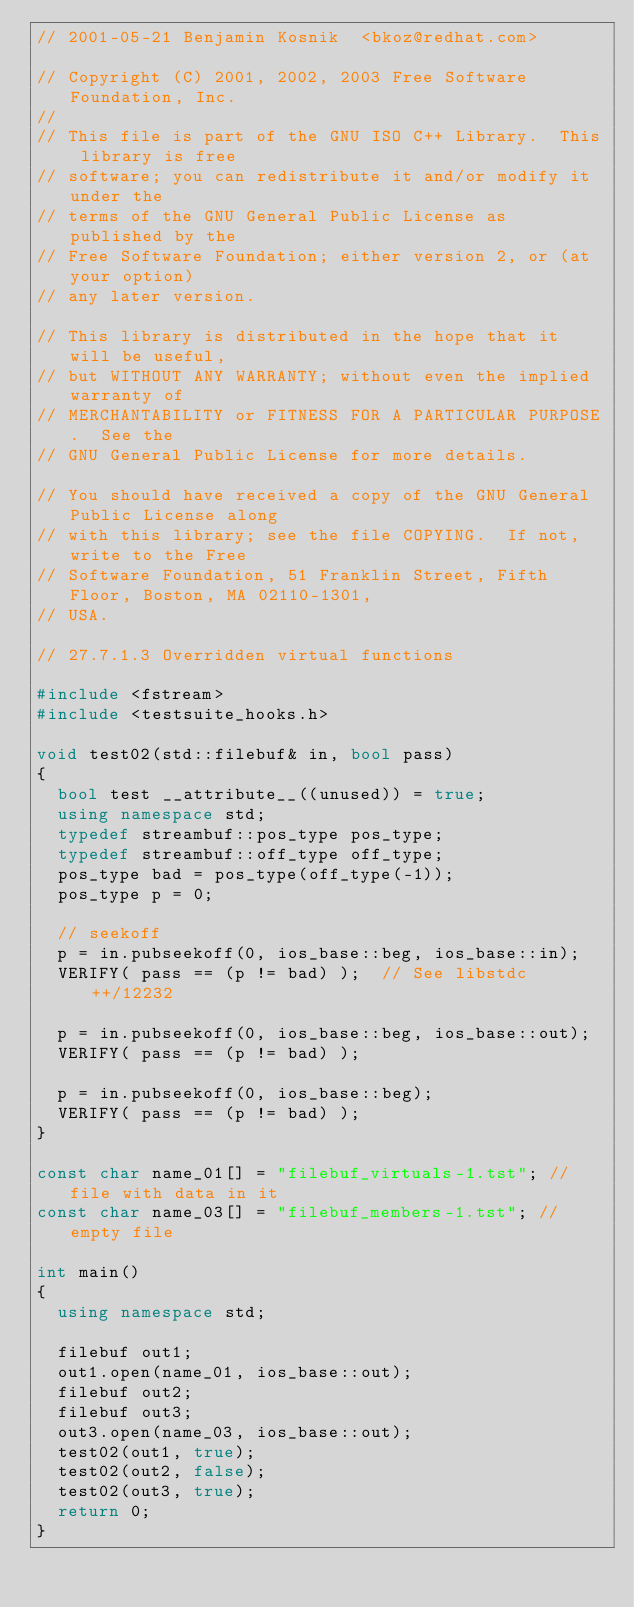Convert code to text. <code><loc_0><loc_0><loc_500><loc_500><_C++_>// 2001-05-21 Benjamin Kosnik  <bkoz@redhat.com>

// Copyright (C) 2001, 2002, 2003 Free Software Foundation, Inc.
//
// This file is part of the GNU ISO C++ Library.  This library is free
// software; you can redistribute it and/or modify it under the
// terms of the GNU General Public License as published by the
// Free Software Foundation; either version 2, or (at your option)
// any later version.

// This library is distributed in the hope that it will be useful,
// but WITHOUT ANY WARRANTY; without even the implied warranty of
// MERCHANTABILITY or FITNESS FOR A PARTICULAR PURPOSE.  See the
// GNU General Public License for more details.

// You should have received a copy of the GNU General Public License along
// with this library; see the file COPYING.  If not, write to the Free
// Software Foundation, 51 Franklin Street, Fifth Floor, Boston, MA 02110-1301,
// USA.

// 27.7.1.3 Overridden virtual functions

#include <fstream>
#include <testsuite_hooks.h>

void test02(std::filebuf& in, bool pass)
{
  bool test __attribute__((unused)) = true;
  using namespace std;
  typedef streambuf::pos_type pos_type;
  typedef streambuf::off_type off_type;
  pos_type bad = pos_type(off_type(-1));
  pos_type p = 0;

  // seekoff
  p = in.pubseekoff(0, ios_base::beg, ios_base::in);
  VERIFY( pass == (p != bad) );  // See libstdc++/12232

  p = in.pubseekoff(0, ios_base::beg, ios_base::out); 
  VERIFY( pass == (p != bad) );

  p = in.pubseekoff(0, ios_base::beg); 
  VERIFY( pass == (p != bad) );
}

const char name_01[] = "filebuf_virtuals-1.tst"; // file with data in it
const char name_03[] = "filebuf_members-1.tst"; // empty file

int main() 
{
  using namespace std;

  filebuf out1;
  out1.open(name_01, ios_base::out);
  filebuf out2;
  filebuf out3;
  out3.open(name_03, ios_base::out);
  test02(out1, true);
  test02(out2, false);
  test02(out3, true);
  return 0;
}
</code> 